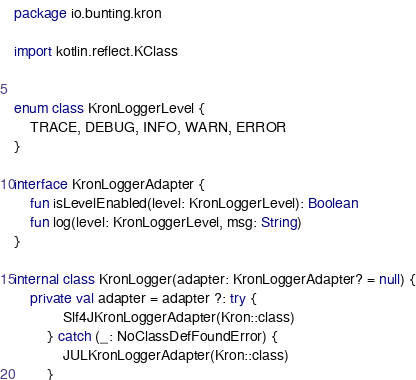Convert code to text. <code><loc_0><loc_0><loc_500><loc_500><_Kotlin_>package io.bunting.kron

import kotlin.reflect.KClass


enum class KronLoggerLevel {
    TRACE, DEBUG, INFO, WARN, ERROR
}

interface KronLoggerAdapter {
    fun isLevelEnabled(level: KronLoggerLevel): Boolean
    fun log(level: KronLoggerLevel, msg: String)
}

internal class KronLogger(adapter: KronLoggerAdapter? = null) {
    private val adapter = adapter ?: try {
            Slf4JKronLoggerAdapter(Kron::class)
        } catch (_: NoClassDefFoundError) {
            JULKronLoggerAdapter(Kron::class)
        }
</code> 